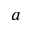Convert formula to latex. <formula><loc_0><loc_0><loc_500><loc_500>a</formula> 